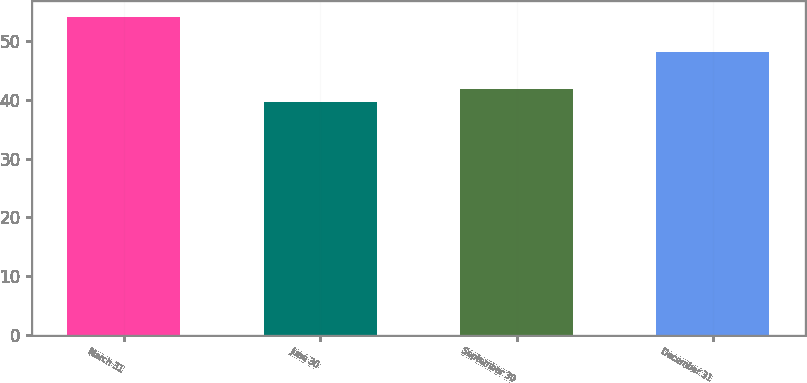Convert chart to OTSL. <chart><loc_0><loc_0><loc_500><loc_500><bar_chart><fcel>March 31<fcel>June 30<fcel>September 30<fcel>December 31<nl><fcel>54.1<fcel>39.67<fcel>41.94<fcel>48.2<nl></chart> 